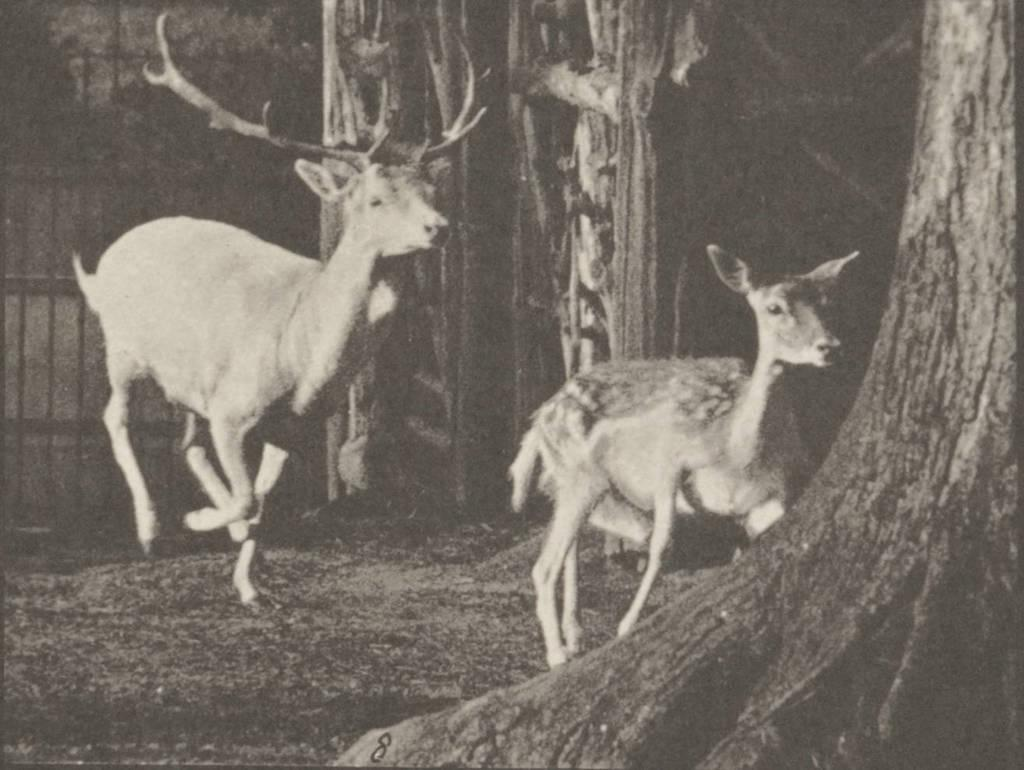What animals can be seen in the image? There are two deer in the image. What are the deer doing in the image? The deer are running on the ground. What type of vegetation is visible in the image? There are tree trunks visible in the image. What object can be used for cooking in the image? There is a grill in the image. What type of pickle is being served on the grill in the image? There is no pickle present in the image, and the grill is not being used for serving food. Is the queen present in the image? There is no mention of a queen or any human figure in the image; it primarily features deer and tree trunks. 